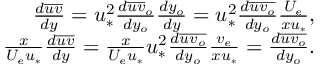<formula> <loc_0><loc_0><loc_500><loc_500>\begin{array} { r } { \frac { d \overline { u v } } { d y } = u _ { * } ^ { 2 } \frac { d \overline { u v } _ { o } } { d y _ { o } } \frac { d y _ { o } } { d y } = u _ { * } ^ { 2 } \frac { d \overline { { u v _ { o } } } } { d y _ { o } } \frac { U _ { e } } { x u _ { * } } , } \\ { \frac { x } { U _ { e } u _ { * } } \frac { d \overline { u v } } { d y } = \frac { x } { U _ { e } u _ { * } } u _ { * } ^ { 2 } \frac { d \overline { { u v _ { o } } } } { d y _ { o } } \frac { v _ { e } } { x u _ { * } } = \frac { d \overline { { u v _ { o } } } } { d y _ { o } } . } \end{array}</formula> 